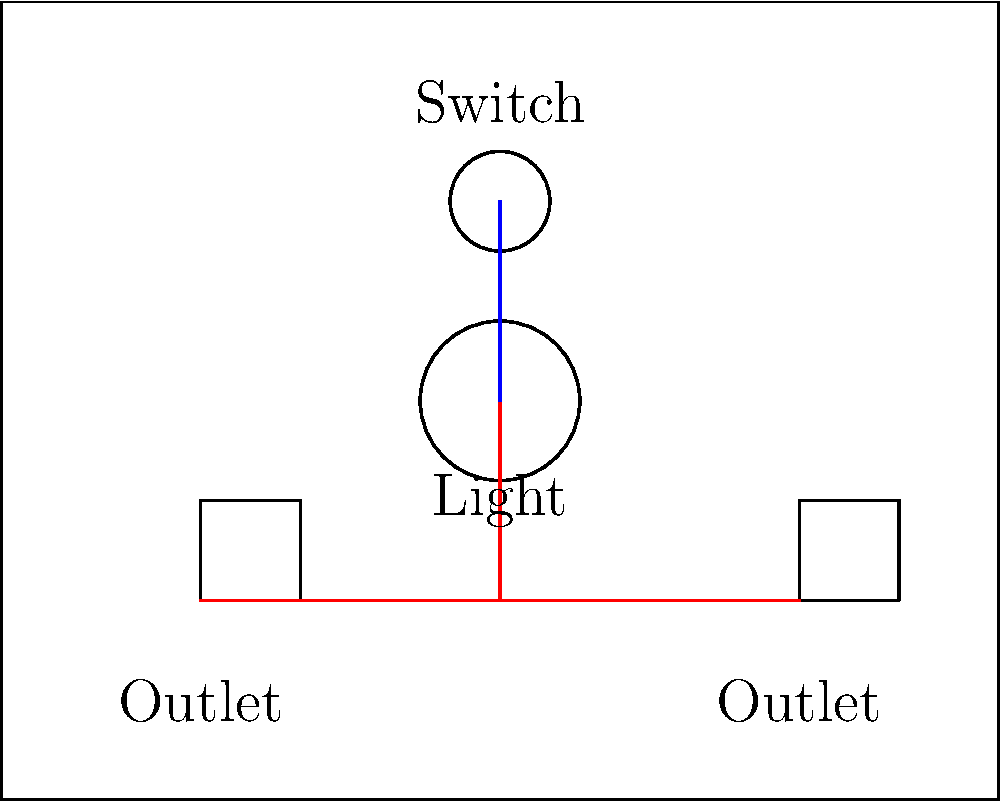In this basic home wiring diagram, what does the circle with a smaller circle inside represent, and how is it connected to the other components? Let's break down the diagram step-by-step:

1. The large rectangle represents a room or area of a house.
2. There are two squares near the bottom of the diagram, labeled "Outlet". These represent electrical outlets.
3. Near the top of the diagram, there's a small circle, labeled "Switch". This represents a light switch.
4. In the center of the diagram, there's a larger circle labeled "Light". This is the symbol for a ceiling light fixture.
5. The red lines represent the hot wires, which carry electricity from the power source to the devices.
6. The blue line represents the switched wire, which connects the switch to the light fixture.

The circle with a smaller circle inside, labeled "Light", represents a ceiling light fixture. It's connected to the other components in the following way:

1. It's connected to the switch (small circle at the top) by a blue line, which represents the switched wire.
2. The switch is connected to one of the outlets by a red line, representing the hot wire that supplies power.

This configuration allows the switch to control the power flow to the light fixture, enabling you to turn the light on and off.
Answer: Ceiling light fixture; connected to switch via switched wire and indirectly to outlet via hot wire. 